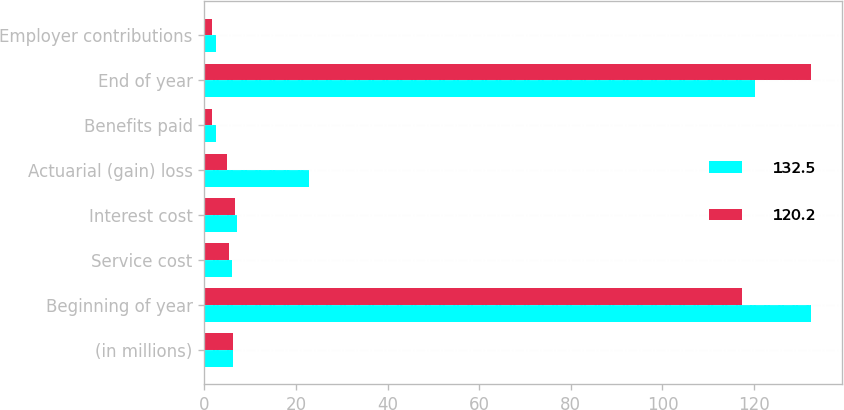Convert chart to OTSL. <chart><loc_0><loc_0><loc_500><loc_500><stacked_bar_chart><ecel><fcel>(in millions)<fcel>Beginning of year<fcel>Service cost<fcel>Interest cost<fcel>Actuarial (gain) loss<fcel>Benefits paid<fcel>End of year<fcel>Employer contributions<nl><fcel>132.5<fcel>6.35<fcel>132.5<fcel>6<fcel>7.2<fcel>22.9<fcel>2.6<fcel>120.2<fcel>2.6<nl><fcel>120.2<fcel>6.35<fcel>117.3<fcel>5.3<fcel>6.7<fcel>4.9<fcel>1.7<fcel>132.5<fcel>1.7<nl></chart> 